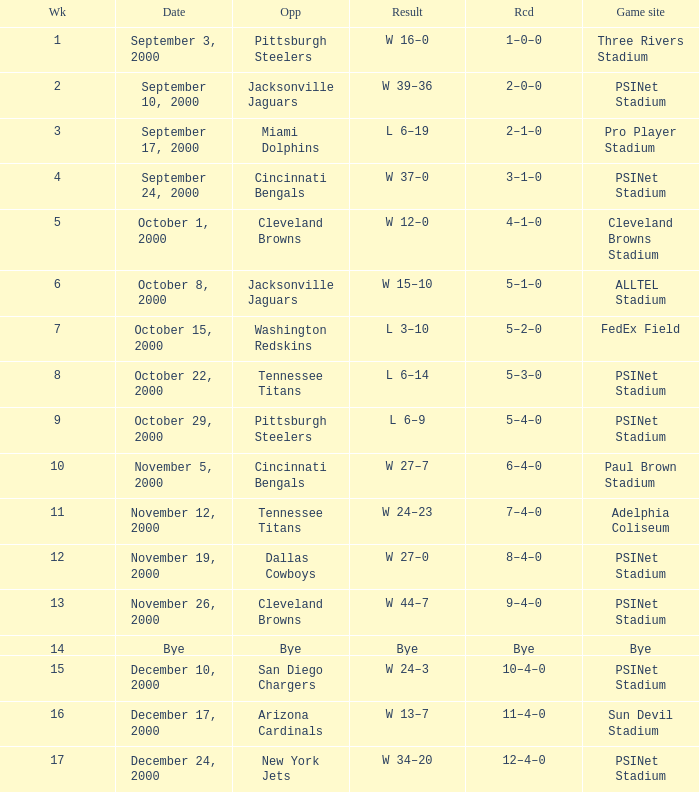What's the record for October 8, 2000 before week 13? 5–1–0. 